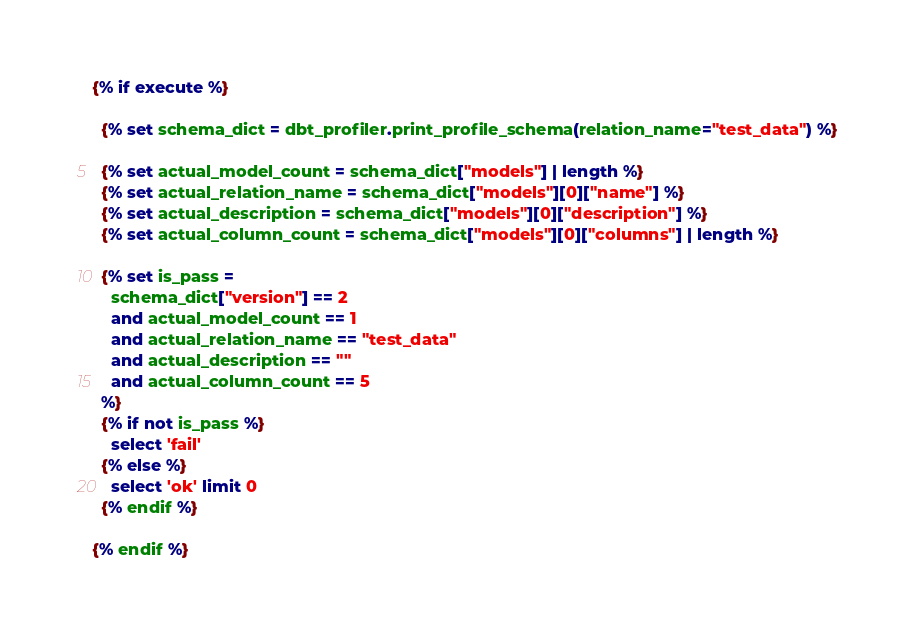Convert code to text. <code><loc_0><loc_0><loc_500><loc_500><_SQL_>{% if execute %}

  {% set schema_dict = dbt_profiler.print_profile_schema(relation_name="test_data") %}

  {% set actual_model_count = schema_dict["models"] | length %}
  {% set actual_relation_name = schema_dict["models"][0]["name"] %}
  {% set actual_description = schema_dict["models"][0]["description"] %}
  {% set actual_column_count = schema_dict["models"][0]["columns"] | length %}
  
  {% set is_pass = 
    schema_dict["version"] == 2 
    and actual_model_count == 1 
    and actual_relation_name == "test_data" 
    and actual_description == ""
    and actual_column_count == 5
  %}
  {% if not is_pass %}
    select 'fail'
  {% else %}
    select 'ok' limit 0
  {% endif %}
  
{% endif %}</code> 